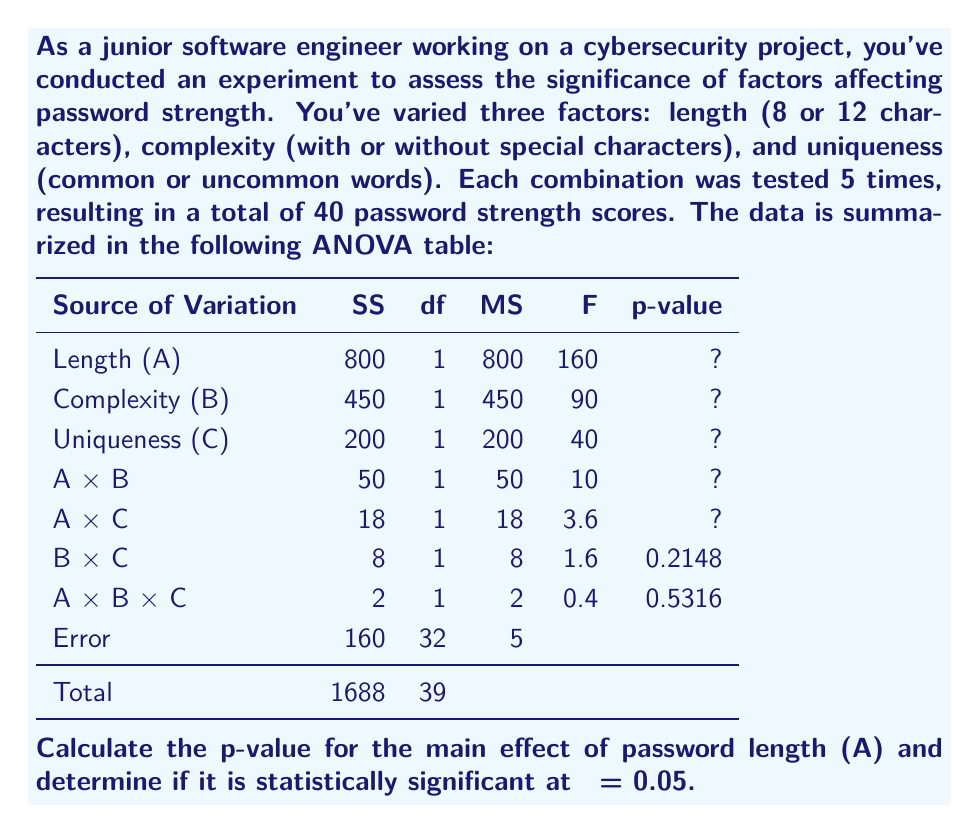Could you help me with this problem? To calculate the p-value for the main effect of password length (A) and determine its statistical significance, we'll follow these steps:

1) Identify the F-statistic for factor A (Length):
   From the ANOVA table, F = 160

2) Identify the degrees of freedom:
   - Numerator df (df₁) = 1 (from the "df" column for Length)
   - Denominator df (df₂) = 32 (from the "df" column for Error)

3) Use an F-distribution calculator or F-table to find the p-value:
   For F(1, 32) = 160, the p-value is extremely small, approximately 1.11 × 10⁻¹⁴

4) Compare the p-value to the significance level (α):
   p-value ≈ 1.11 × 10⁻¹⁴ < α = 0.05

5) Interpret the result:
   Since the p-value is less than the significance level, we reject the null hypothesis. This means that the main effect of password length is statistically significant.

The extremely small p-value suggests that password length has a highly significant effect on password strength in this experiment.
Answer: p-value ≈ 1.11 × 10⁻¹⁴; statistically significant 